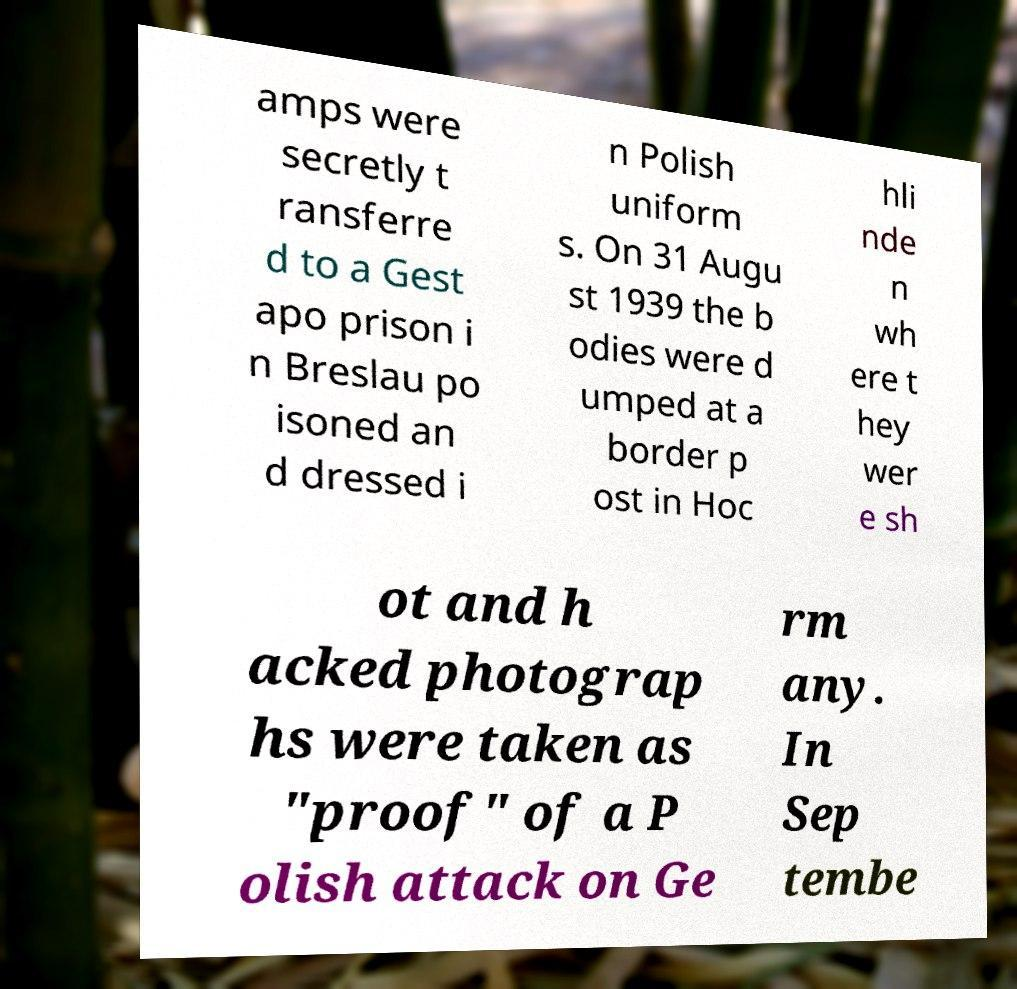I need the written content from this picture converted into text. Can you do that? amps were secretly t ransferre d to a Gest apo prison i n Breslau po isoned an d dressed i n Polish uniform s. On 31 Augu st 1939 the b odies were d umped at a border p ost in Hoc hli nde n wh ere t hey wer e sh ot and h acked photograp hs were taken as "proof" of a P olish attack on Ge rm any. In Sep tembe 